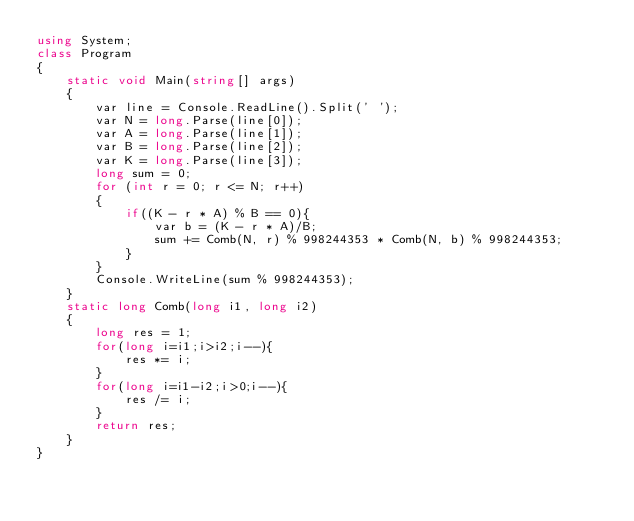Convert code to text. <code><loc_0><loc_0><loc_500><loc_500><_C#_>using System;
class Program
{
    static void Main(string[] args)
    {
        var line = Console.ReadLine().Split(' ');
        var N = long.Parse(line[0]);
        var A = long.Parse(line[1]);
        var B = long.Parse(line[2]);
        var K = long.Parse(line[3]);
        long sum = 0;
        for (int r = 0; r <= N; r++)
        {
            if((K - r * A) % B == 0){
                var b = (K - r * A)/B;
                sum += Comb(N, r) % 998244353 * Comb(N, b) % 998244353;
            }
        }
        Console.WriteLine(sum % 998244353);
    }
    static long Comb(long i1, long i2)
    {
        long res = 1;
        for(long i=i1;i>i2;i--){
            res *= i;
        }
        for(long i=i1-i2;i>0;i--){
            res /= i;
        }
        return res;
    }
}
</code> 